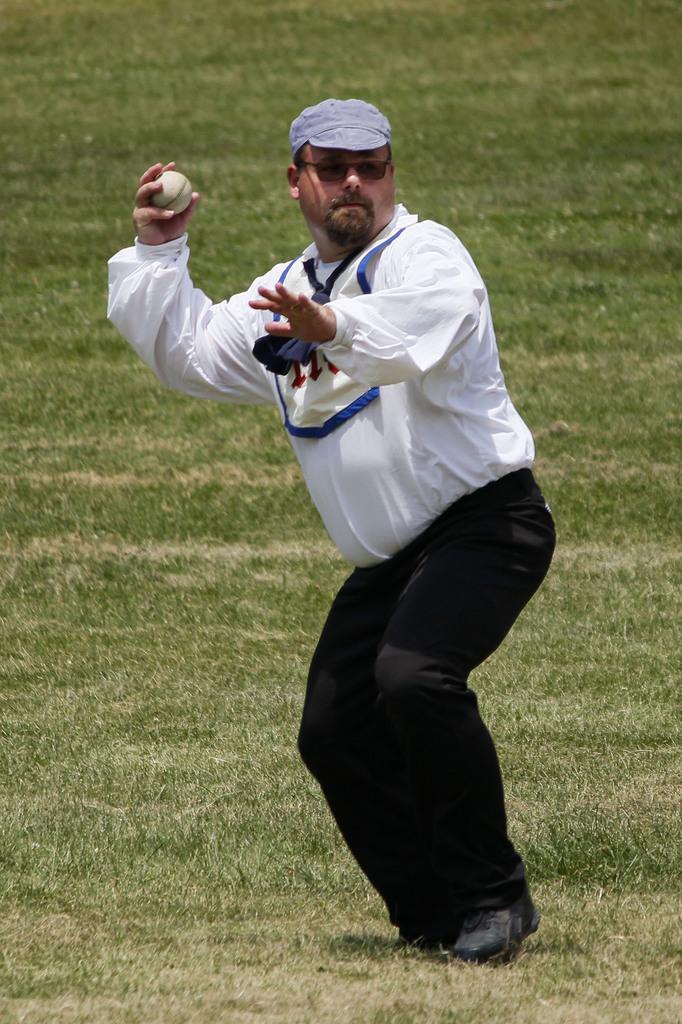How would you summarize this image in a sentence or two? In this image we can see a man standing on the ground holding a ball. We can also see some grass. 